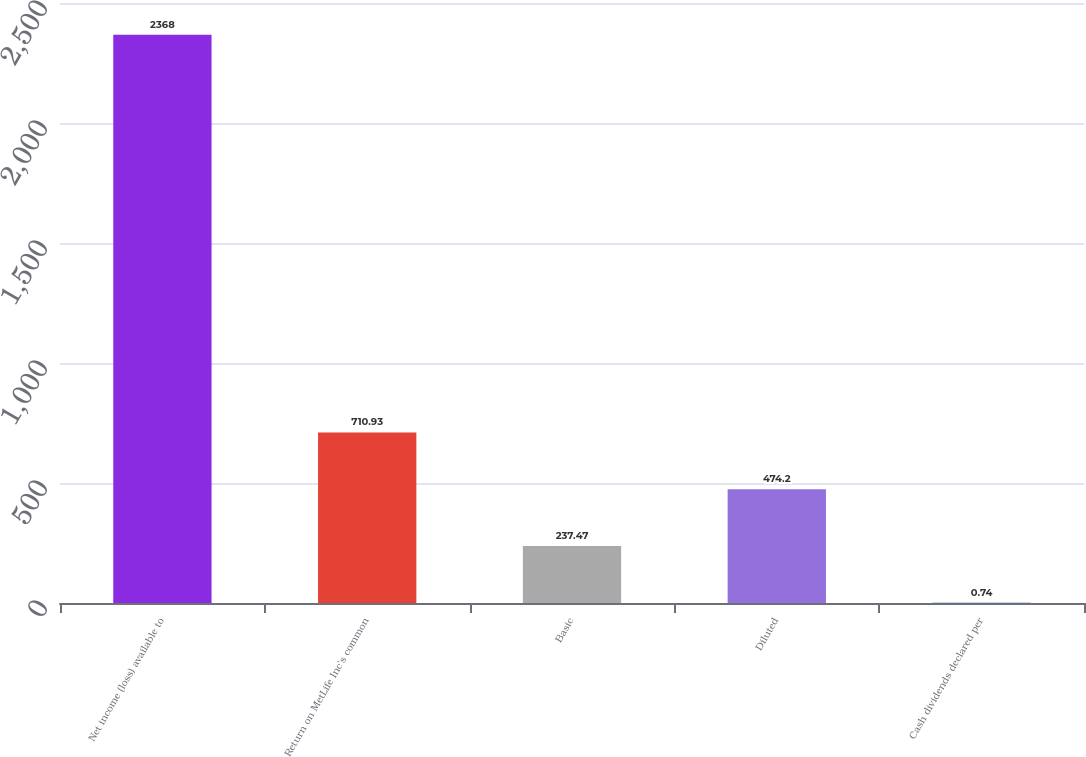<chart> <loc_0><loc_0><loc_500><loc_500><bar_chart><fcel>Net income (loss) available to<fcel>Return on MetLife Inc's common<fcel>Basic<fcel>Diluted<fcel>Cash dividends declared per<nl><fcel>2368<fcel>710.93<fcel>237.47<fcel>474.2<fcel>0.74<nl></chart> 